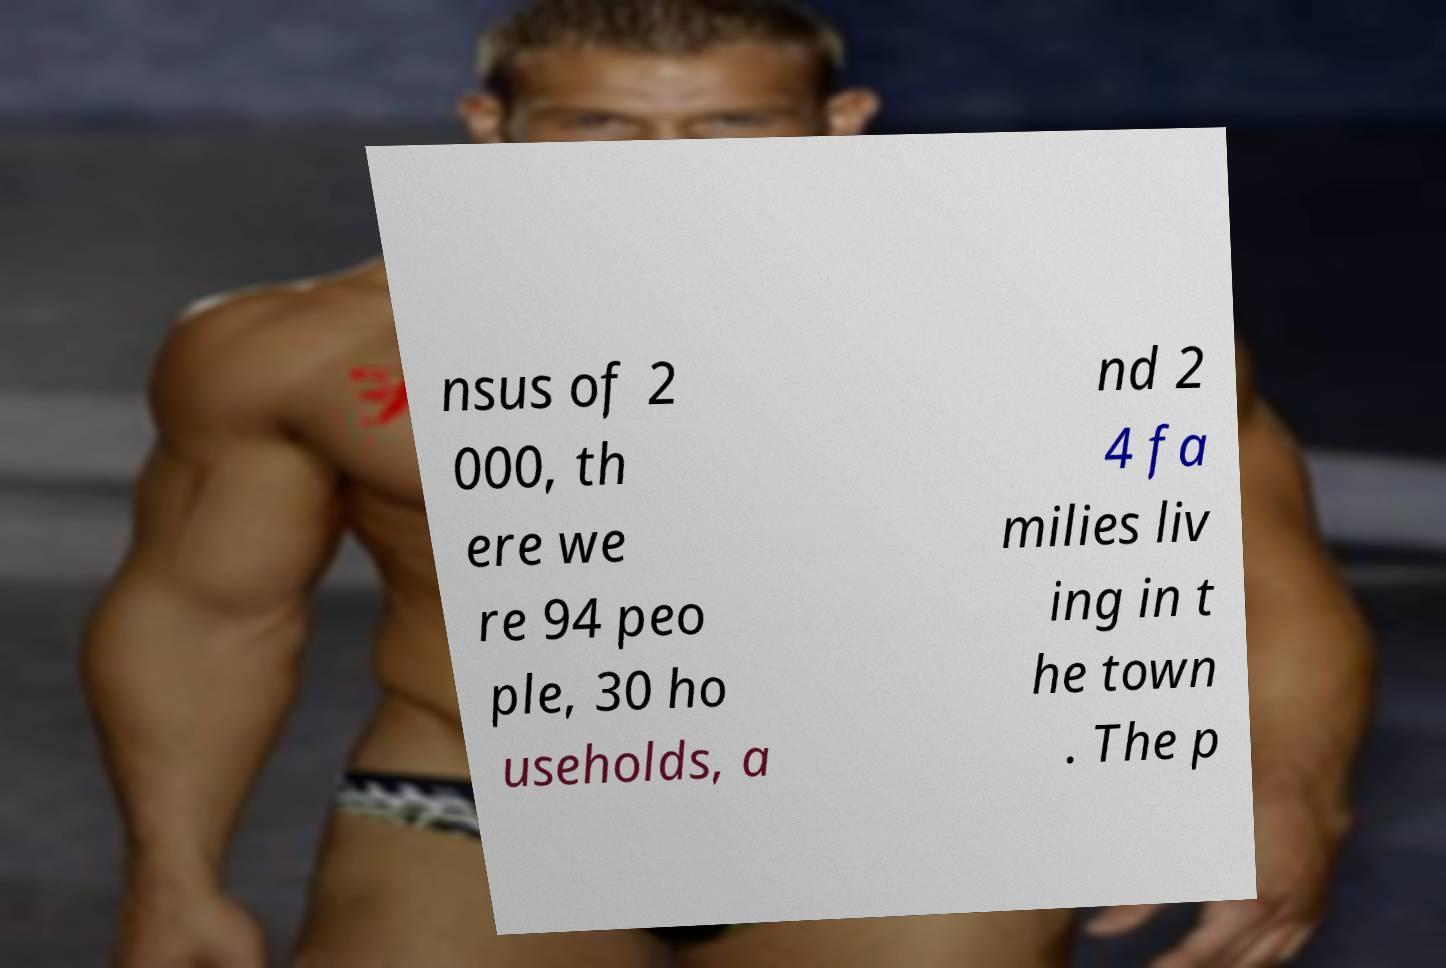I need the written content from this picture converted into text. Can you do that? nsus of 2 000, th ere we re 94 peo ple, 30 ho useholds, a nd 2 4 fa milies liv ing in t he town . The p 